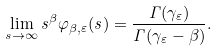Convert formula to latex. <formula><loc_0><loc_0><loc_500><loc_500>\lim _ { s \to \infty } s ^ { \beta } \varphi _ { \beta , \varepsilon } ( s ) = \frac { \Gamma ( \gamma _ { \varepsilon } ) } { \Gamma ( \gamma _ { \varepsilon } - \beta ) } .</formula> 